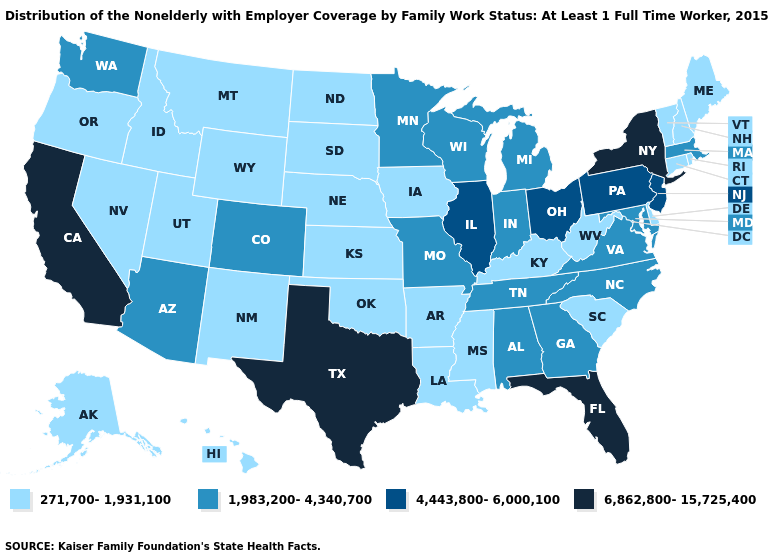What is the value of Kentucky?
Concise answer only. 271,700-1,931,100. Name the states that have a value in the range 271,700-1,931,100?
Write a very short answer. Alaska, Arkansas, Connecticut, Delaware, Hawaii, Idaho, Iowa, Kansas, Kentucky, Louisiana, Maine, Mississippi, Montana, Nebraska, Nevada, New Hampshire, New Mexico, North Dakota, Oklahoma, Oregon, Rhode Island, South Carolina, South Dakota, Utah, Vermont, West Virginia, Wyoming. What is the highest value in the Northeast ?
Write a very short answer. 6,862,800-15,725,400. Name the states that have a value in the range 1,983,200-4,340,700?
Concise answer only. Alabama, Arizona, Colorado, Georgia, Indiana, Maryland, Massachusetts, Michigan, Minnesota, Missouri, North Carolina, Tennessee, Virginia, Washington, Wisconsin. How many symbols are there in the legend?
Short answer required. 4. Which states have the lowest value in the South?
Concise answer only. Arkansas, Delaware, Kentucky, Louisiana, Mississippi, Oklahoma, South Carolina, West Virginia. Which states have the lowest value in the Northeast?
Concise answer only. Connecticut, Maine, New Hampshire, Rhode Island, Vermont. Among the states that border Texas , which have the lowest value?
Be succinct. Arkansas, Louisiana, New Mexico, Oklahoma. What is the value of Connecticut?
Short answer required. 271,700-1,931,100. Does Illinois have the same value as Oregon?
Be succinct. No. Which states have the lowest value in the USA?
Give a very brief answer. Alaska, Arkansas, Connecticut, Delaware, Hawaii, Idaho, Iowa, Kansas, Kentucky, Louisiana, Maine, Mississippi, Montana, Nebraska, Nevada, New Hampshire, New Mexico, North Dakota, Oklahoma, Oregon, Rhode Island, South Carolina, South Dakota, Utah, Vermont, West Virginia, Wyoming. Does Kansas have the lowest value in the MidWest?
Quick response, please. Yes. What is the value of South Carolina?
Give a very brief answer. 271,700-1,931,100. What is the value of California?
Be succinct. 6,862,800-15,725,400. 